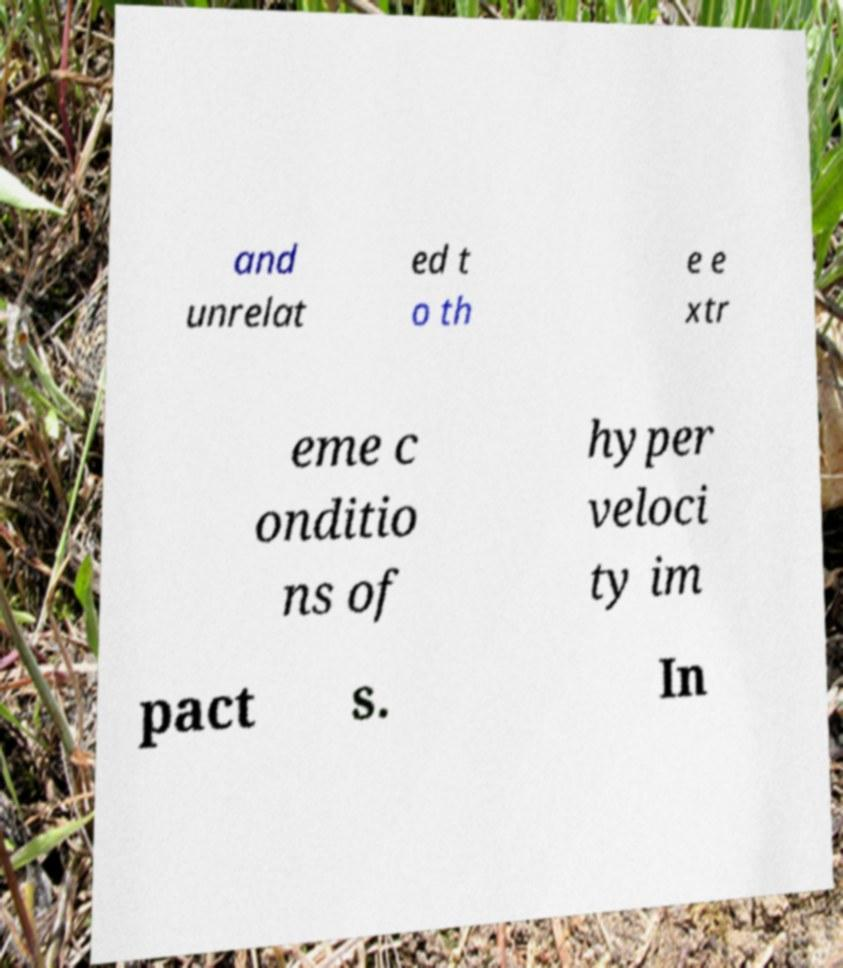There's text embedded in this image that I need extracted. Can you transcribe it verbatim? and unrelat ed t o th e e xtr eme c onditio ns of hyper veloci ty im pact s. In 